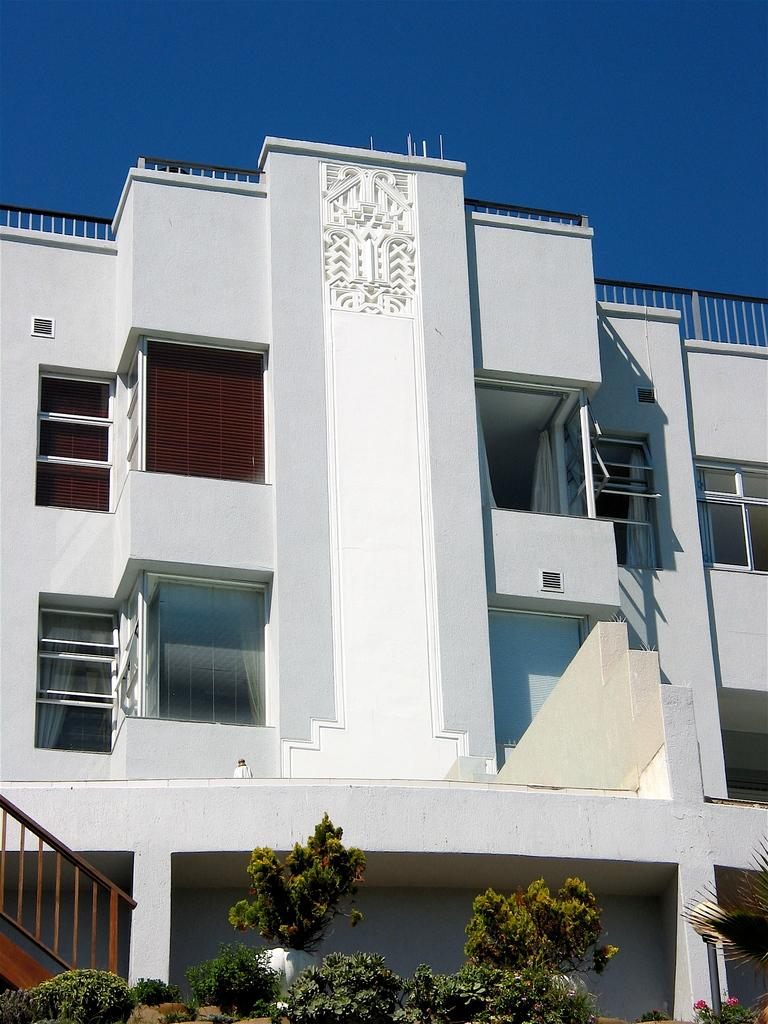What type of vegetation is visible in the front of the image? There are plants in the front of the image. What structure can be seen in the background of the image? There is a building in the background of the image. What is the color of the building? The building is white in color. What architectural feature is present on the left side of the building? There is a staircase on the left side of the building. What type of peace symbol can be seen on the roof of the building? There is no peace symbol present on the roof of the building in the image. What type of copper material is used in the construction of the staircase? There is no mention of copper material being used in the construction of the staircase; it is not visible in the image. 